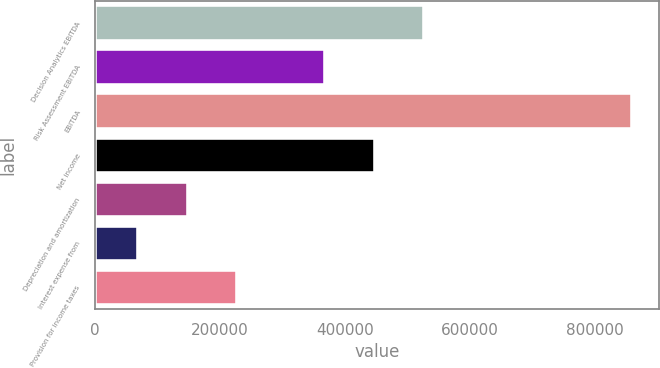Convert chart to OTSL. <chart><loc_0><loc_0><loc_500><loc_500><bar_chart><fcel>Decision Analytics EBITDA<fcel>Risk Assessment EBITDA<fcel>EBITDA<fcel>Net income<fcel>Depreciation and amortization<fcel>Interest expense from<fcel>Provision for income taxes<nl><fcel>526487<fcel>368770<fcel>858568<fcel>447628<fcel>148842<fcel>69984<fcel>227701<nl></chart> 